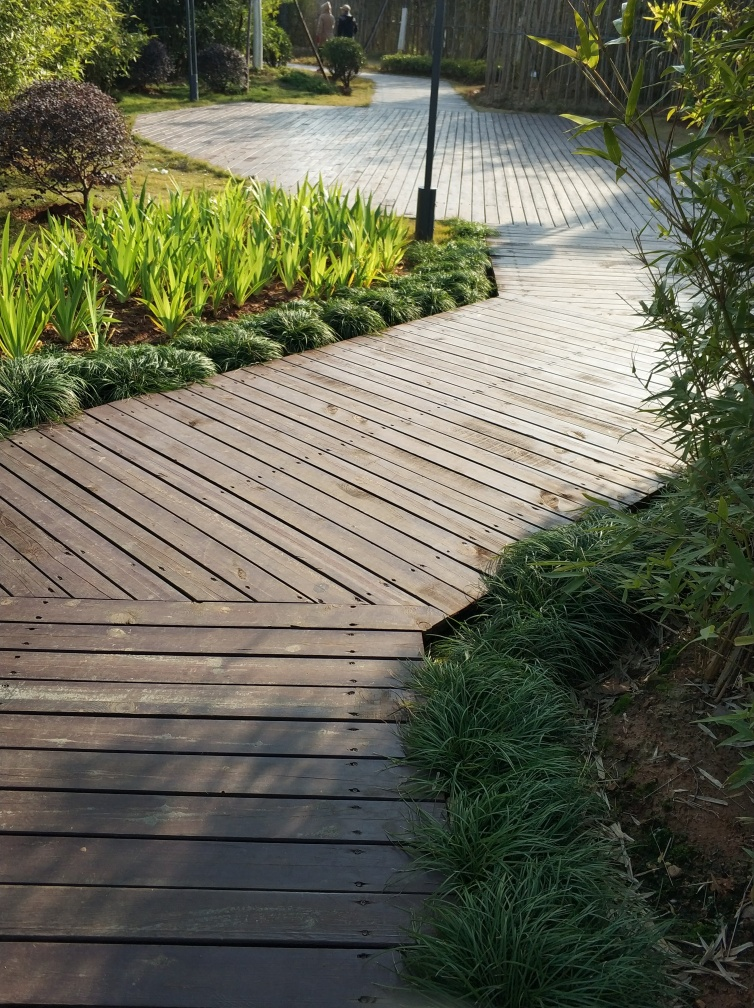Does the photo have good quality? The quality of the photo can be considered good based on the sharp details, correct exposure, and balanced composition present. The viewer can appreciate the textures of the wooden path, the grass, and plants, as well as the play of light and shadow that adds depth to the scene. 